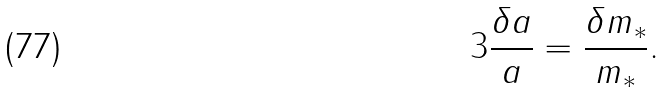<formula> <loc_0><loc_0><loc_500><loc_500>3 \frac { \delta a } { a } = \frac { \delta m _ { * } } { m _ { * } } .</formula> 